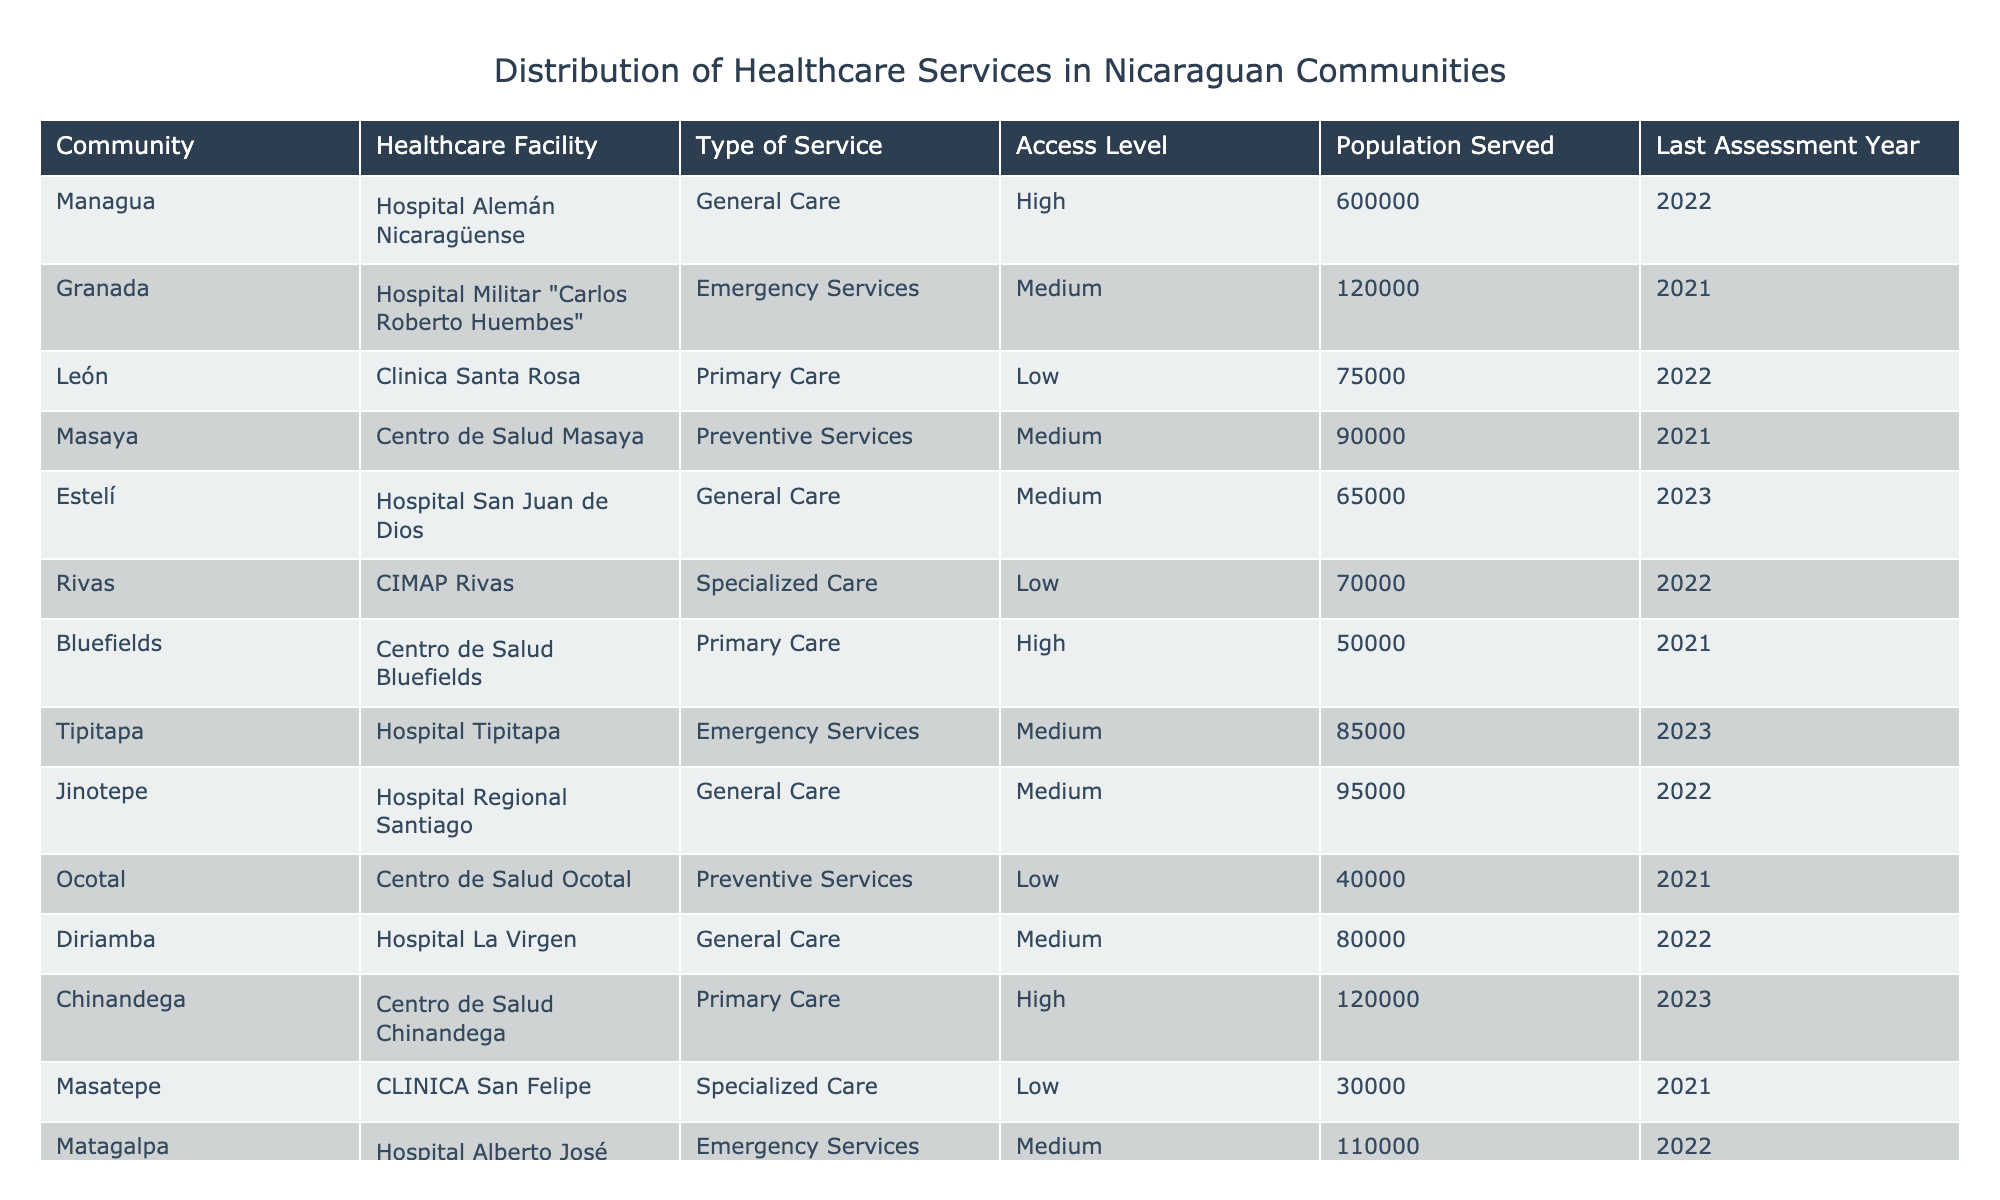What community has the highest population served? Looking through the table, I see that Managua has a population served of 600,000, which is the highest among all communities listed.
Answer: Managua How many healthcare facilities in total provide Emergency Services? The table shows two facilities that offer Emergency Services: Hospital Militar "Carlos Roberto Huembes" in Granada and Hospital Tipitapa in Tipitapa.
Answer: 2 What is the type of service provided by Centro de Salud Ocotal? The table indicates that Centro de Salud Ocotal provides Preventive Services.
Answer: Preventive Services Which community has the lowest access level to healthcare services? By examining the access levels listed in the table, I find that Rivas, León, and Ocotal each have a Low access level, which is the lowest possible level.
Answer: Rivas, León, Ocotal What is the average population served by healthcare facilities providing General Care? I gather the populations served for General Care facilities: 600,000 (Managua), 65,000 (Estelí), and 80,000 (Diriamba) which sum to 745,000. There are three such facilities, so the average is 745,000 / 3 = 248,333.33.
Answer: 248,333 Which type of service has the highest number of facilities? In reviewing the table, I find that Primary Care has three facilities: Clinica Santa Rosa in León, Centro de Salud Bluefields, and Centro de Salud Chinandega.
Answer: Primary Care Is there any community that has a specialized care facility and what is its access level? Upon checking the table, I find that the community Rivas has CIMAP Rivas as the specialized care facility, which has a Low access level.
Answer: Yes, Rivas, Low Which two communities have preventive services and what are their access levels? Looking at the table, I find that Centro de Salud Masaya (Masaya) and Centro de Salud Ticuantepe (Ticuantepe) provide Preventive Services, both with Medium access levels.
Answer: Masaya, Ticuantepe; Medium How many healthcare facilities have an access level of High? Scanning the table, I find that there are three facilities with High access level: Hospital Alemán Nicaragüense (Managua), Centro de Salud Bluefields, and Centro de Salud Chinandega.
Answer: 3 What is the total population served by healthcare facilities in communities with Medium access level? I identify the facilities with Medium access level: 120,000 (Granada), 65,000 (Estelí), 85,000 (Tipitapa), 95,000 (Jinotepe), 80,000 (Diriamba), and 110,000 (Matagalpa). The total population served is 120,000 + 65,000 + 85,000 + 95,000 + 80,000 + 110,000 = 555,000.
Answer: 555,000 Which facility provides General Care and is located in Estelí? The table lists Hospital San Juan de Dios in Estelí as providing General Care.
Answer: Hospital San Juan de Dios 